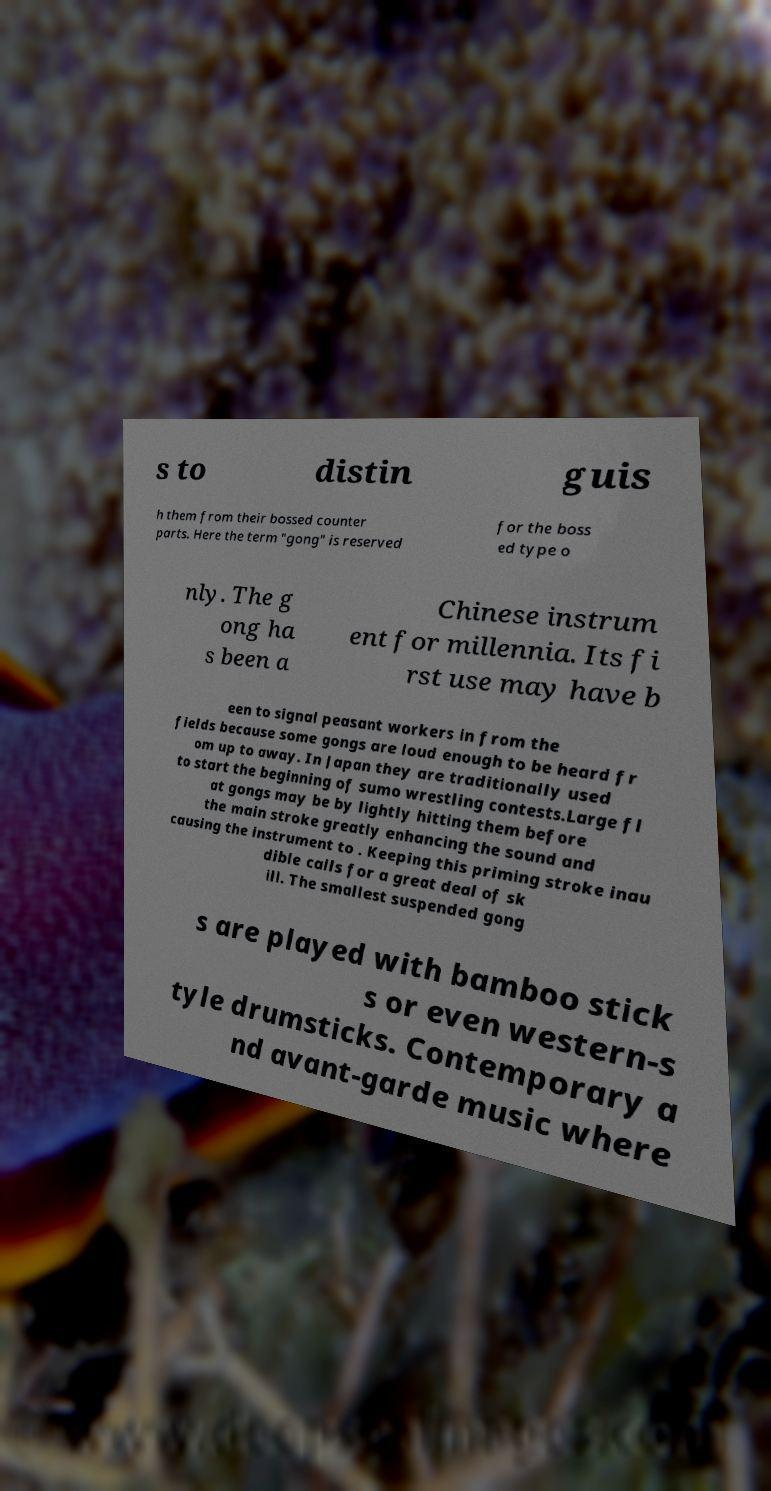Please read and relay the text visible in this image. What does it say? s to distin guis h them from their bossed counter parts. Here the term "gong" is reserved for the boss ed type o nly. The g ong ha s been a Chinese instrum ent for millennia. Its fi rst use may have b een to signal peasant workers in from the fields because some gongs are loud enough to be heard fr om up to away. In Japan they are traditionally used to start the beginning of sumo wrestling contests.Large fl at gongs may be by lightly hitting them before the main stroke greatly enhancing the sound and causing the instrument to . Keeping this priming stroke inau dible calls for a great deal of sk ill. The smallest suspended gong s are played with bamboo stick s or even western-s tyle drumsticks. Contemporary a nd avant-garde music where 